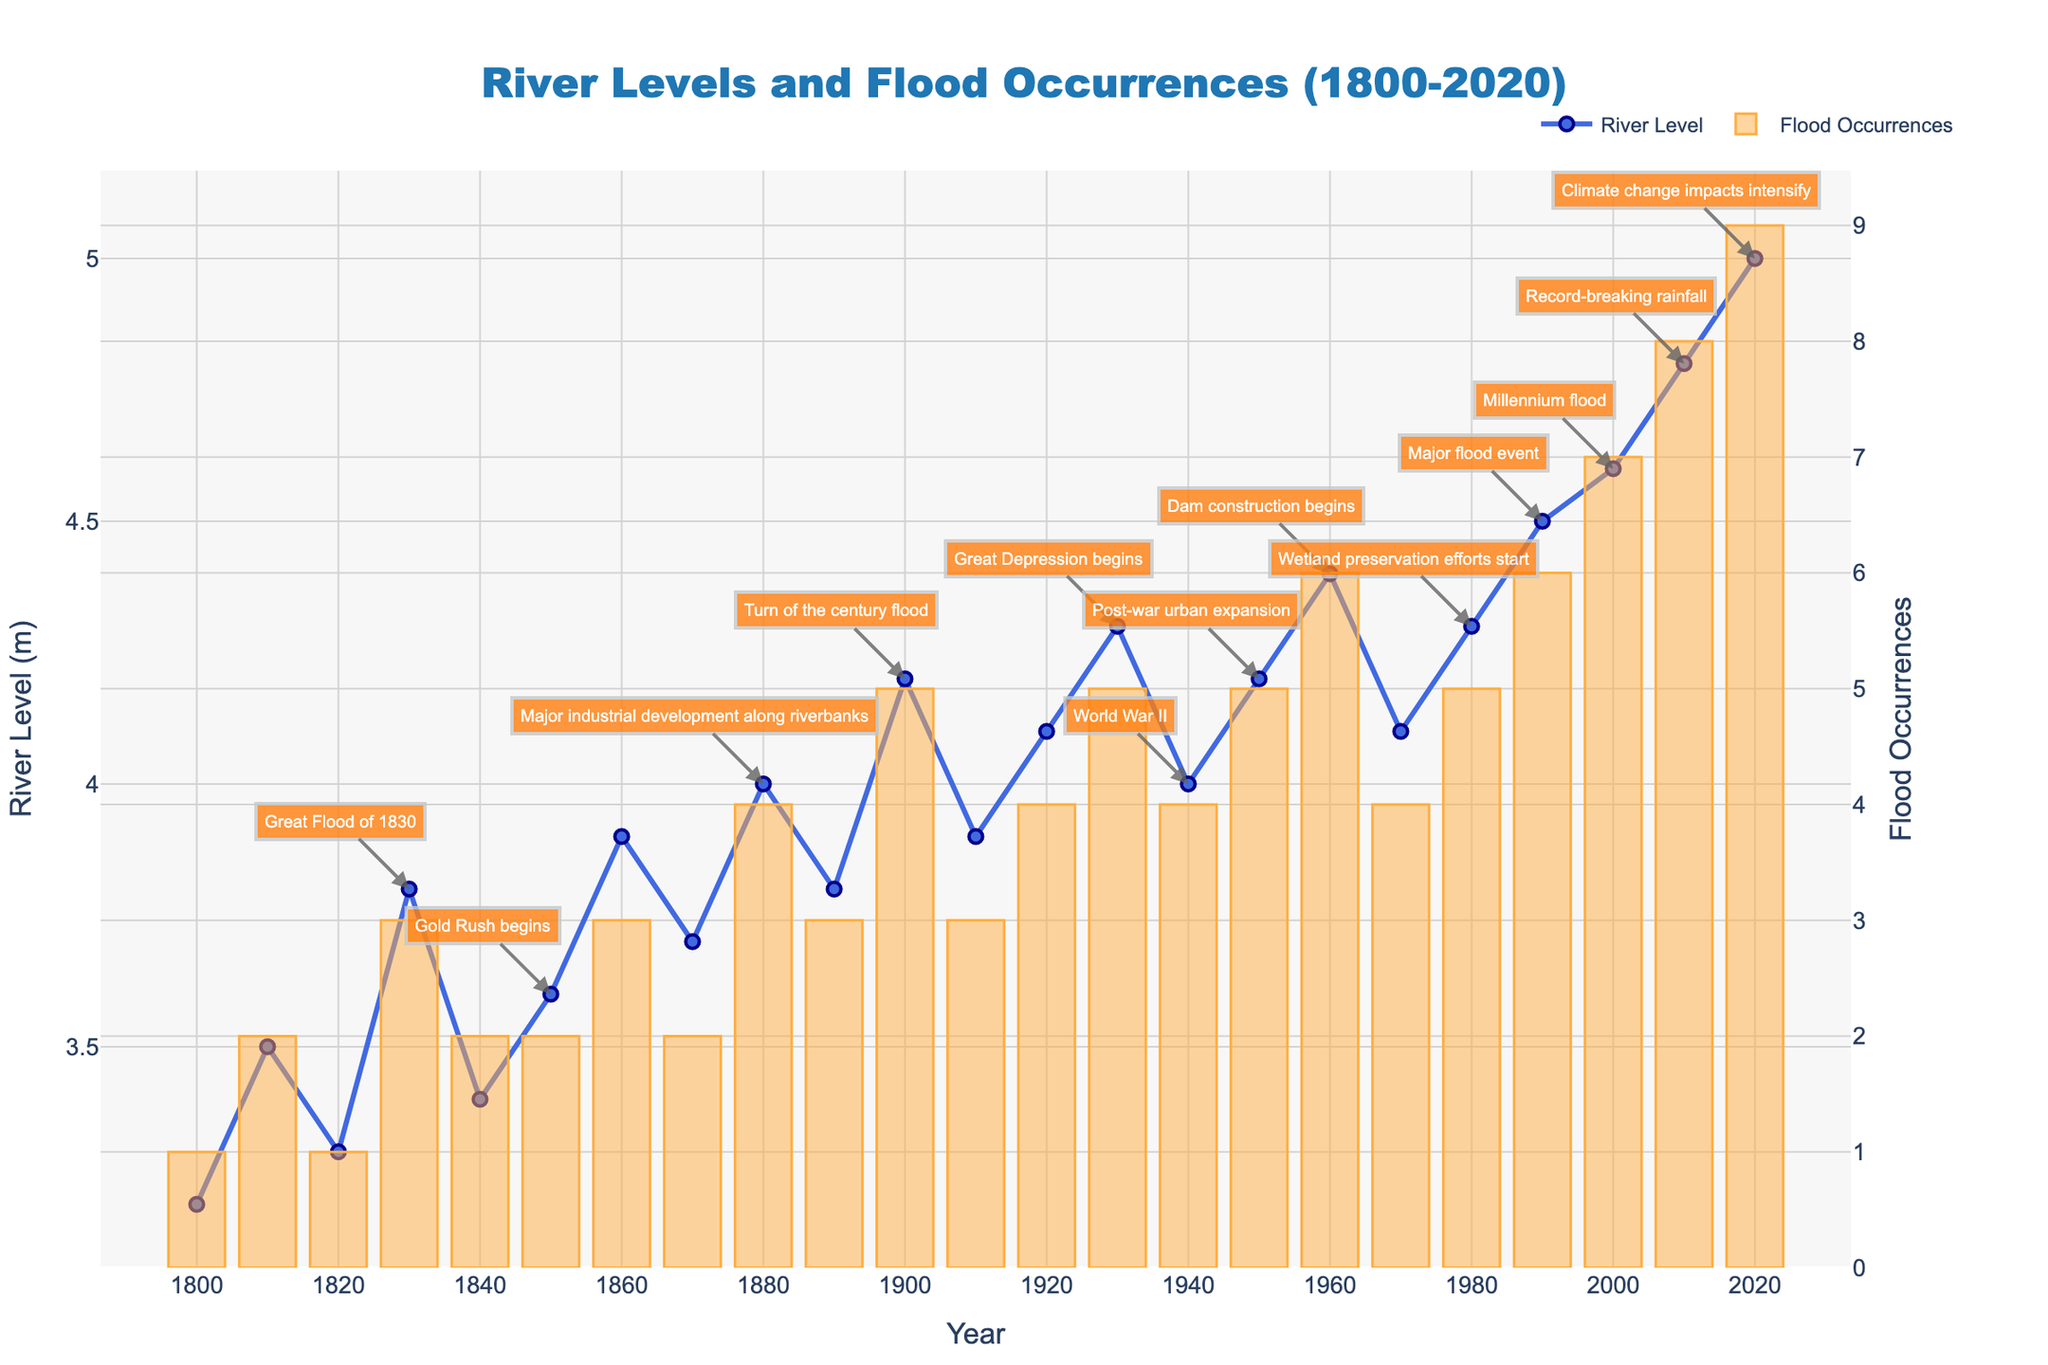What historical event is annotated in the 1830s? The figure shows an annotation for a historical event named "Great Flood of 1830" in the 1830s on the line chart for river levels.
Answer: Great Flood of 1830 Which decade experienced the most flood occurrences? By looking at the height of the bars representing flood occurrences, the 2020s (2020-2029) have the tallest bar with 9 flood occurrences.
Answer: 2020s How did river levels change between the beginning of the Great Depression and the start of World War II? The Great Depression is annotated in 1930 with a river level of 4.3 meters, and World War II is annotated in 1940 with a river level of 4.0 meters. The river level decreased by 0.3 meters during this period.
Answer: Decreased by 0.3 meters In which years do the annotations occur where the river level is above 4.5 meters? The annotations that occur above the 4.5-meter river level mark are "Major flood event" in 1990, "Millennium flood" in 2000, "Record-breaking rainfall" in 2010, and "Climate change impacts intensify" in 2020.
Answer: 1990, 2000, 2010, 2020 What is the average number of flood occurrences per decade from 1900 to 2000? Calculate the flood occurrences in each decade from 1900 to 2000: 1900-4, 1910-3, 1920-4, 1930-5, 1940-4, 1950-5, 1960-6, 1970-4, 1980-5, 1990-6. The sum is 4+3+4+5+4+5+6+4+5+6 = 46. There are 10 decades, so the average is 46/10 = 4.6.
Answer: 4.6 flood occurrences per decade What are the river levels at the start and end of the period shown in the figure? The river level at the start of the period (1800) is 3.2 meters, and at the end of the period (2020) is 5.0 meters, according to the line chart.
Answer: 3.2 meters in 1800 and 5.0 meters in 2020 How do the flood occurrences in 1930 compare with those in 1950? The bar for 1930 indicates 5 flood occurrences, while the bar for 1950 also indicates 5 flood occurrences. Therefore, the number of flood occurrences in 1930 is equal to those in 1950.
Answer: Equal Which historical event coincides with the highest river level recorded in the data? The highest river level recorded is 5.0 meters in 2020, and the annotation is "Climate change impacts intensify" at this point.
Answer: Climate change impacts intensify Compare the changes in river level and flood occurrences between the Gold Rush and the Great Depression. During the Gold Rush in 1850, the river level was 3.6 meters and 2 flood occurrences. In 1930, during the Great Depression, the river level was 4.3 meters with 5 flood occurrences. The river level increased by 0.7 meters and flood occurrences increased by 3.
Answer: River level increased by 0.7 meters and flood occurrences increased by 3 